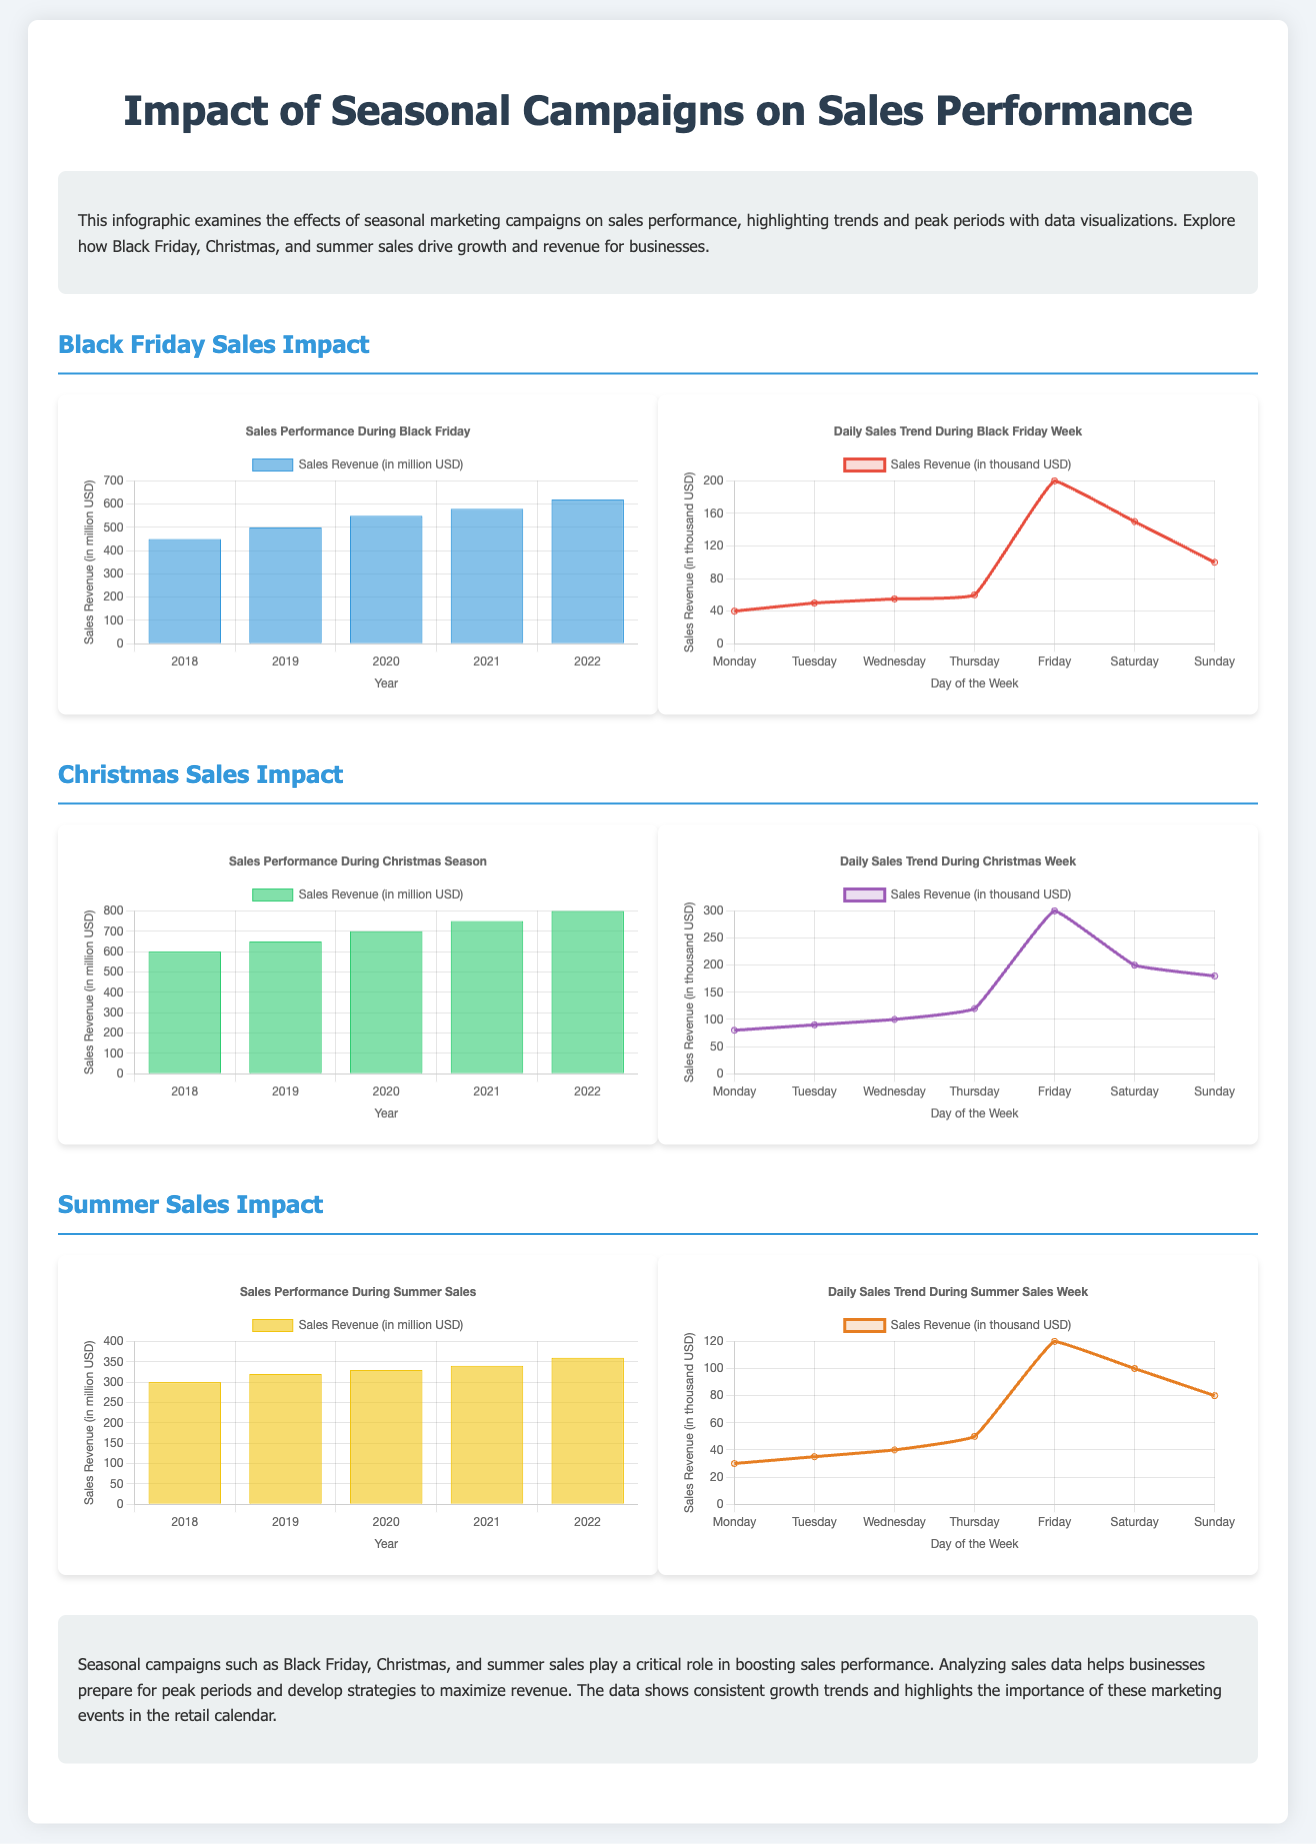What year had the highest Black Friday sales revenue? The bar chart shows Black Friday sales revenue for the years 2018 to 2022, with 2022 having the highest value of 620 million USD.
Answer: 2022 What was the sales revenue on Christmas Day in 2021? The line chart for Christmas sales indicates that 2021 had a revenue of 300 thousand USD on Christmas Day, which is noted on the chart.
Answer: 300 How much did summer sales revenue increase from 2018 to 2022? The bar chart shows summer sales revenue going from 300 million USD in 2018 to 360 million USD in 2022, indicating a growth of 60 million USD.
Answer: 60 million USD What day of the week has the peak sales during Black Friday week? The line chart shows that Friday has the highest sales revenue of 200 thousand USD during Black Friday week.
Answer: Friday How much was the total sales revenue during the Christmas season for 2020? The bar chart shows that Christmas sales revenue in 2020 was 700 million USD, as clearly depicted in the chart.
Answer: 700 million USD Which seasonal campaign had the highest sales revenue over the years displayed? Comparing the bar charts, Christmas sales consistently had the highest revenue, especially in 2022 at 800 million USD.
Answer: Christmas What is the primary purpose of this infographic? The introduction states that the infographic examines the effects of seasonal marketing campaigns on sales performance.
Answer: Examine effects of seasonal marketing campaigns What was the sales revenue for Summer Sales in 2020? According to the bar chart for summer sales, the revenue for 2020 was 330 million USD.
Answer: 330 million USD What does the line chart for summer sales depict in terms of daily revenue? The line chart illustrates daily sales trends during the Summer Sales week, showing variations day to day.
Answer: Daily sales trends 